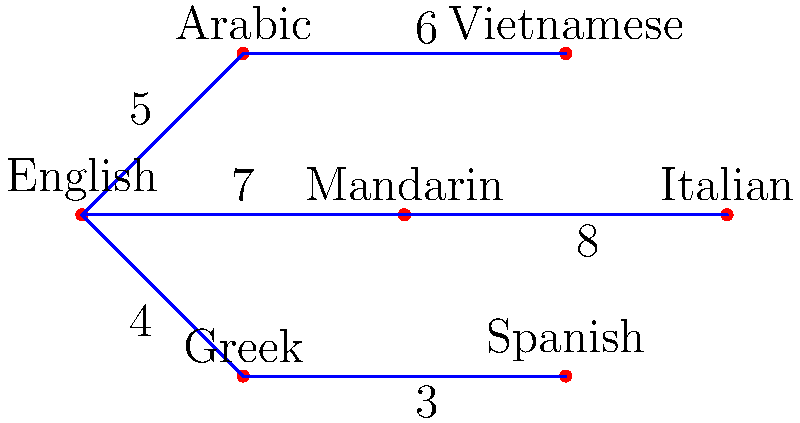In a multicultural neighborhood of Western Sydney, different language communities are represented as nodes in a graph. The edges represent potential translation services between communities, with weights indicating the cost of establishing these services. Using the minimum spanning tree algorithm, what is the total cost of connecting all language communities in the most efficient way? To find the minimum spanning tree (MST) and calculate the total cost, we'll use Kruskal's algorithm:

1. Sort the edges by weight in ascending order:
   (Greek - Spanish): 3
   (English - Greek): 4
   (English - Arabic): 5
   (Arabic - Vietnamese): 6
   (English - Mandarin): 7
   (Mandarin - Italian): 8

2. Add edges to the MST, avoiding cycles:
   a) Add (Greek - Spanish): 3
   b) Add (English - Greek): 4
   c) Add (English - Arabic): 5
   d) Add (Arabic - Vietnamese): 6
   e) Add (English - Mandarin): 7
   f) Skip (Mandarin - Italian) as it would create a cycle

3. The MST is now complete, connecting all nodes.

4. Calculate the total cost by summing the weights of the edges in the MST:
   $3 + 4 + 5 + 6 + 7 = 25$

Therefore, the total cost of connecting all language communities in the most efficient way is 25.
Answer: 25 